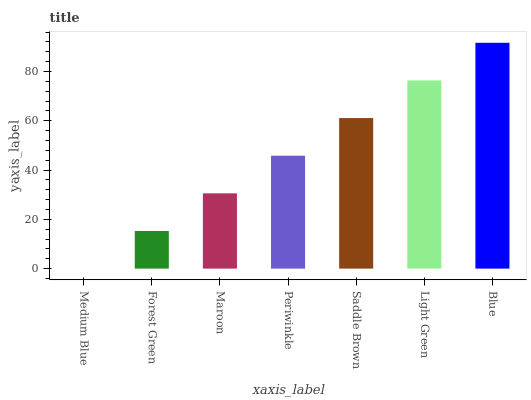Is Medium Blue the minimum?
Answer yes or no. Yes. Is Blue the maximum?
Answer yes or no. Yes. Is Forest Green the minimum?
Answer yes or no. No. Is Forest Green the maximum?
Answer yes or no. No. Is Forest Green greater than Medium Blue?
Answer yes or no. Yes. Is Medium Blue less than Forest Green?
Answer yes or no. Yes. Is Medium Blue greater than Forest Green?
Answer yes or no. No. Is Forest Green less than Medium Blue?
Answer yes or no. No. Is Periwinkle the high median?
Answer yes or no. Yes. Is Periwinkle the low median?
Answer yes or no. Yes. Is Blue the high median?
Answer yes or no. No. Is Light Green the low median?
Answer yes or no. No. 